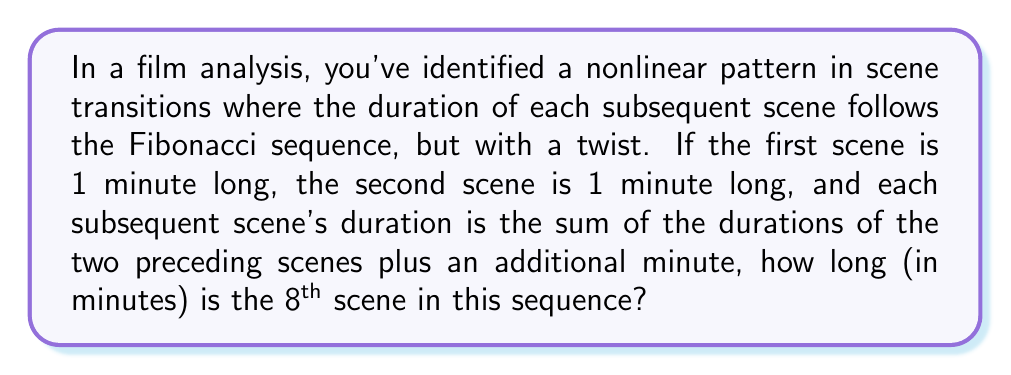Show me your answer to this math problem. Let's approach this step-by-step:

1) First, let's recall the standard Fibonacci sequence:
   1, 1, 2, 3, 5, 8, 13, 21, ...

2) In our modified sequence, we add 1 to each term after the second term. Let's call our sequence $a_n$:

   $a_1 = 1$
   $a_2 = 1$
   $a_n = a_{n-1} + a_{n-2} + 1$ for $n \geq 3$

3) Let's calculate the first 8 terms:

   $a_1 = 1$
   $a_2 = 1$
   $a_3 = 1 + 1 + 1 = 3$
   $a_4 = 3 + 1 + 1 = 5$
   $a_5 = 5 + 3 + 1 = 9$
   $a_6 = 9 + 5 + 1 = 15$
   $a_7 = 15 + 9 + 1 = 25$
   $a_8 = 25 + 15 + 1 = 41$

4) Therefore, the 8th scene in this sequence is 41 minutes long.

This nonlinear pattern creates an interesting rhythm in the film, with scene durations growing at an increasing rate, potentially reflecting escalating tension or complexity in the narrative.
Answer: 41 minutes 